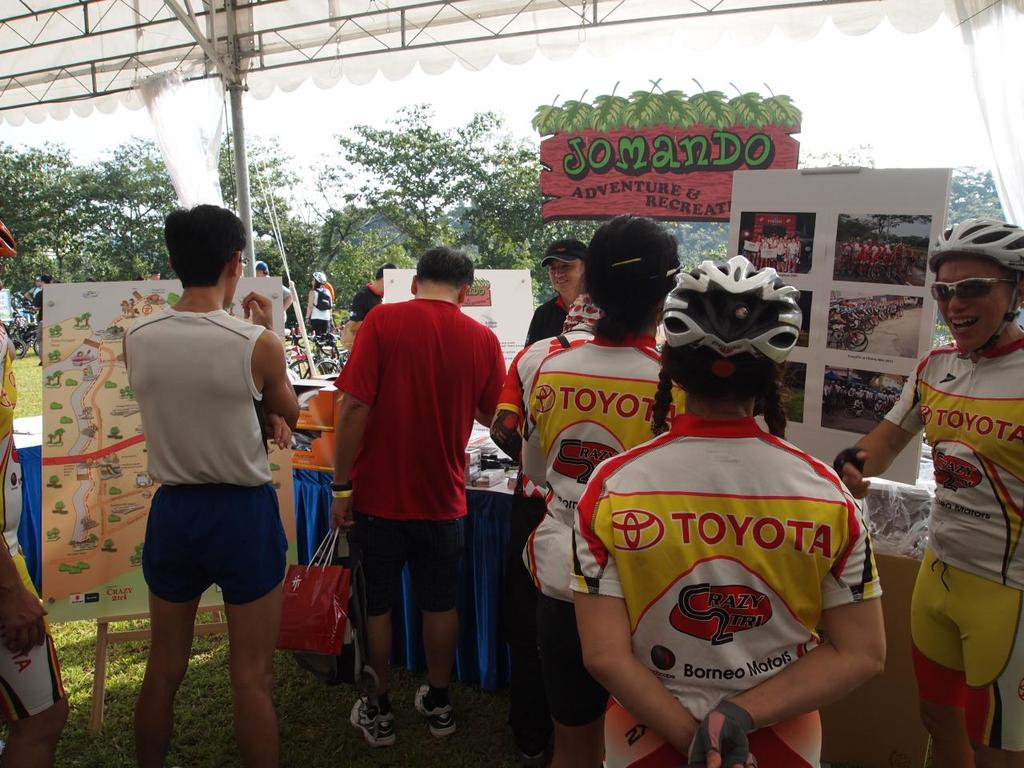Can you describe the atmosphere and setting of the event shown in the image? The setting appears to be a lush, green outdoor area, likely a park or a similar recreational venue. The atmosphere seems casual yet lively, with participants chatting excitedly and engaging with organizers or sponsors in a tented area, reflecting a community-focused or familial environment typical of local sporting events. What role does the sponsor 'Toyota' play in this event? Toyota, as a major sponsor shown on uniforms and potentially other event materials, likely provides financial support or resources, contributing to the organization and execution of the event. Sponsorship by a large corporation like Toyota also helps in promoting the event and drawing in participants and spectators. 